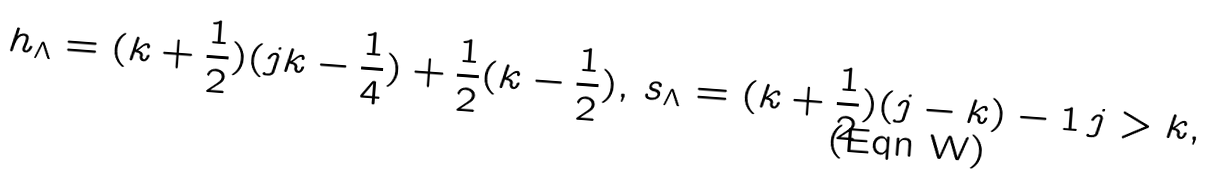<formula> <loc_0><loc_0><loc_500><loc_500>h _ { \Lambda } = ( k + \frac { 1 } { 2 } ) ( j k - \frac { 1 } { 4 } ) + \frac { 1 } { 2 } ( k - \frac { 1 } { 2 } ) , \, s _ { \Lambda } = ( k + \frac { 1 } { 2 } ) ( j - k ) - 1 \, j > k ,</formula> 